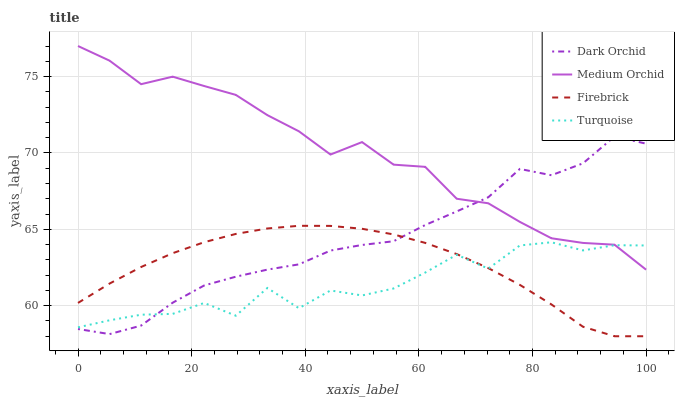Does Turquoise have the minimum area under the curve?
Answer yes or no. Yes. Does Medium Orchid have the maximum area under the curve?
Answer yes or no. Yes. Does Medium Orchid have the minimum area under the curve?
Answer yes or no. No. Does Turquoise have the maximum area under the curve?
Answer yes or no. No. Is Firebrick the smoothest?
Answer yes or no. Yes. Is Turquoise the roughest?
Answer yes or no. Yes. Is Medium Orchid the smoothest?
Answer yes or no. No. Is Medium Orchid the roughest?
Answer yes or no. No. Does Firebrick have the lowest value?
Answer yes or no. Yes. Does Turquoise have the lowest value?
Answer yes or no. No. Does Medium Orchid have the highest value?
Answer yes or no. Yes. Does Turquoise have the highest value?
Answer yes or no. No. Is Firebrick less than Medium Orchid?
Answer yes or no. Yes. Is Medium Orchid greater than Firebrick?
Answer yes or no. Yes. Does Firebrick intersect Dark Orchid?
Answer yes or no. Yes. Is Firebrick less than Dark Orchid?
Answer yes or no. No. Is Firebrick greater than Dark Orchid?
Answer yes or no. No. Does Firebrick intersect Medium Orchid?
Answer yes or no. No. 